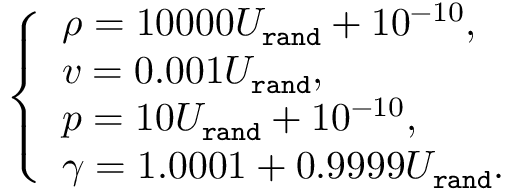<formula> <loc_0><loc_0><loc_500><loc_500>\begin{array} { r } { \left \{ \begin{array} { l l } { \rho = 1 0 0 0 0 U _ { \tt r a n d } + 1 0 ^ { - 1 0 } , } \\ { v = 0 . 0 0 1 U _ { \tt r a n d } , } \\ { p = 1 0 U _ { \tt r a n d } + 1 0 ^ { - 1 0 } , } \\ { \gamma = 1 . 0 0 0 1 + 0 . 9 9 9 9 U _ { \tt r a n d } . } \end{array} } \end{array}</formula> 